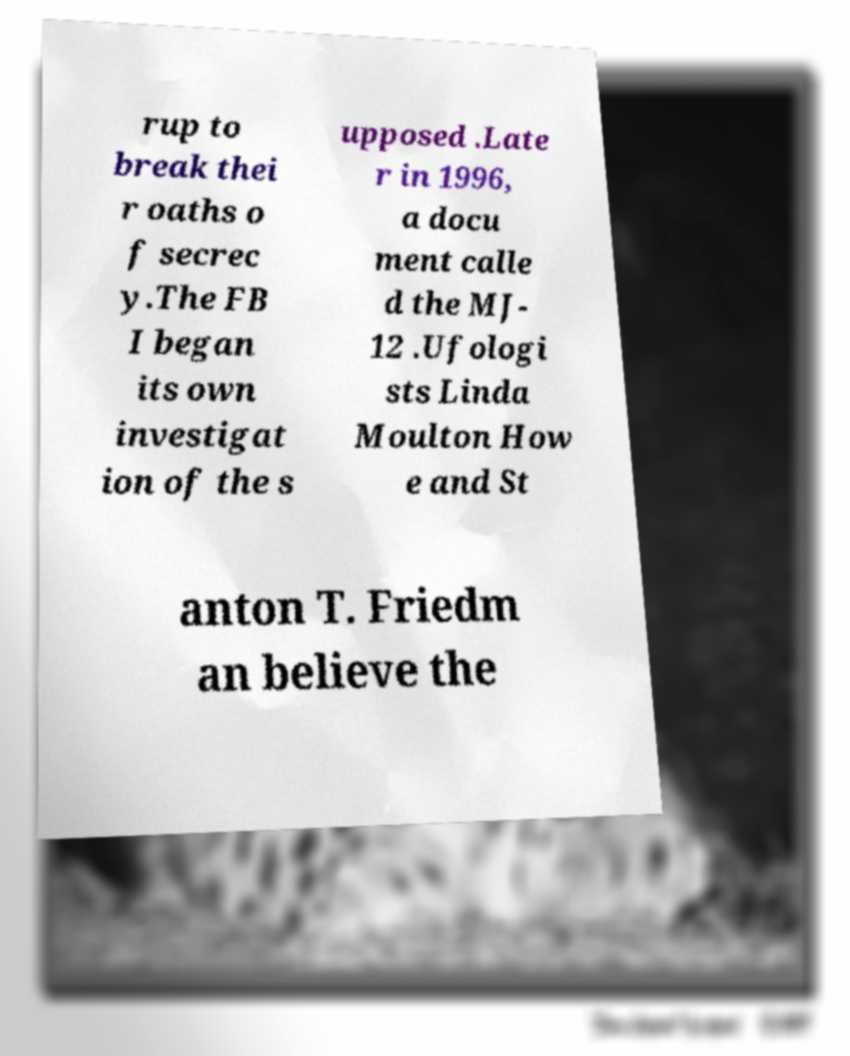Can you accurately transcribe the text from the provided image for me? rup to break thei r oaths o f secrec y.The FB I began its own investigat ion of the s upposed .Late r in 1996, a docu ment calle d the MJ- 12 .Ufologi sts Linda Moulton How e and St anton T. Friedm an believe the 